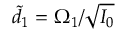Convert formula to latex. <formula><loc_0><loc_0><loc_500><loc_500>\tilde { d } _ { 1 } = \Omega _ { 1 } / \sqrt { I _ { 0 } }</formula> 